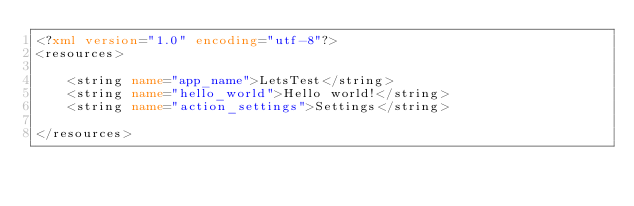<code> <loc_0><loc_0><loc_500><loc_500><_XML_><?xml version="1.0" encoding="utf-8"?>
<resources>

    <string name="app_name">LetsTest</string>
    <string name="hello_world">Hello world!</string>
    <string name="action_settings">Settings</string>

</resources>
</code> 